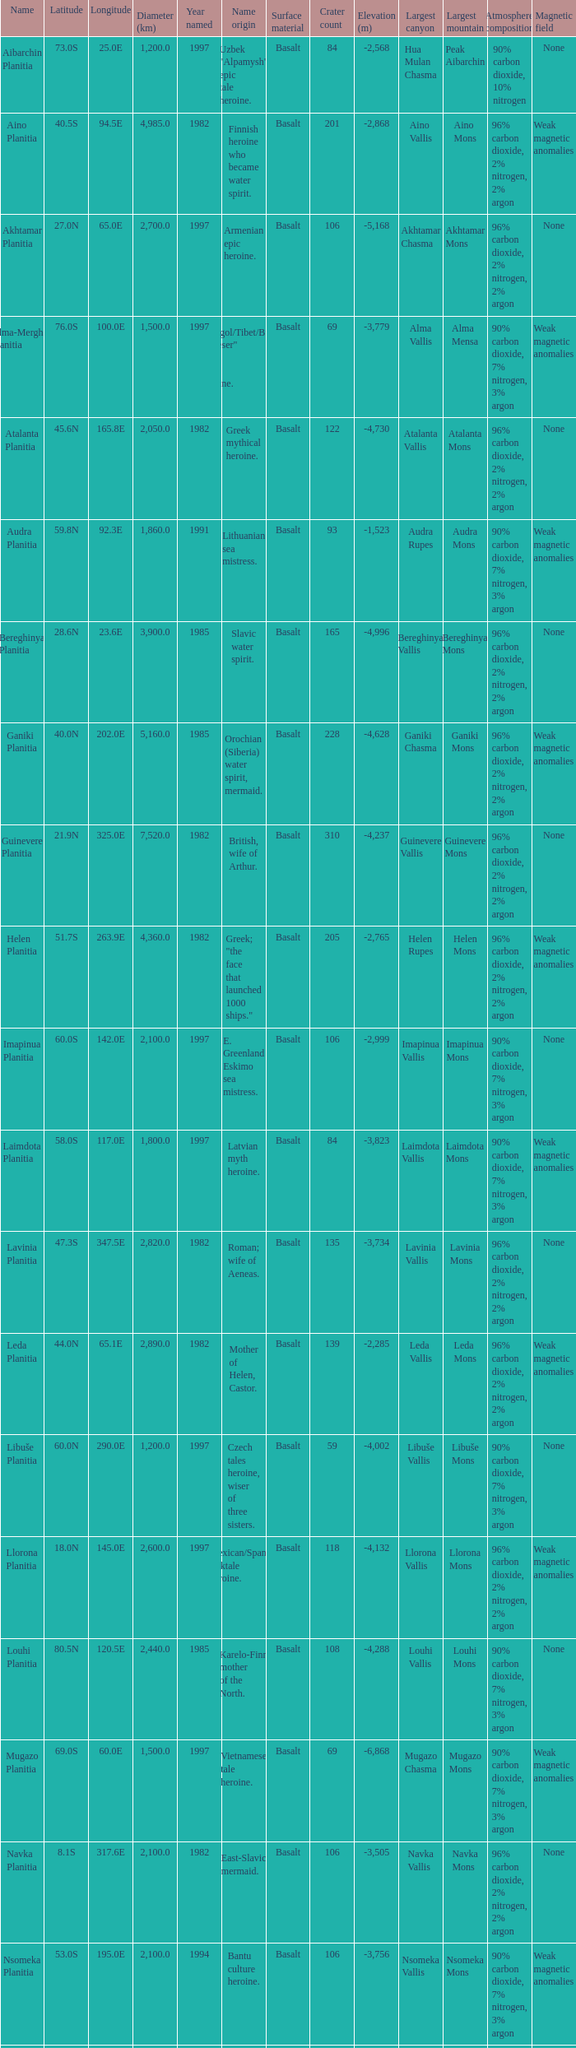0s? 3000.0. 